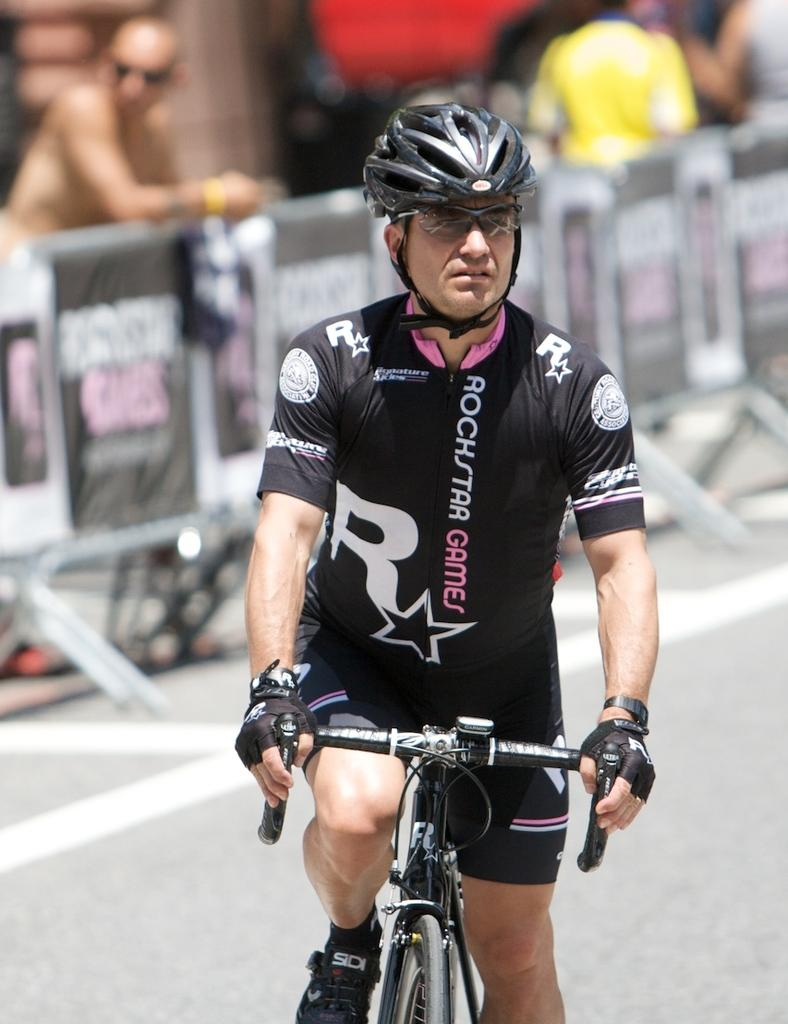What is the man in the image doing? The man is sitting on a bicycle and riding it on the road. What safety precaution is the man taking while riding the bicycle? The man is wearing a helmet. What type of eyewear is the man wearing in the image? The man is wearing glasses. Can you describe the background of the image? There are people visible in the background of the image. What type of curtain can be seen hanging from the bicycle in the image? There is no curtain present in the image; it features a man riding a bicycle on the road. How many rings is the man wearing on his fingers in the image? There is no mention of rings in the image; the man is wearing a helmet and glasses. 